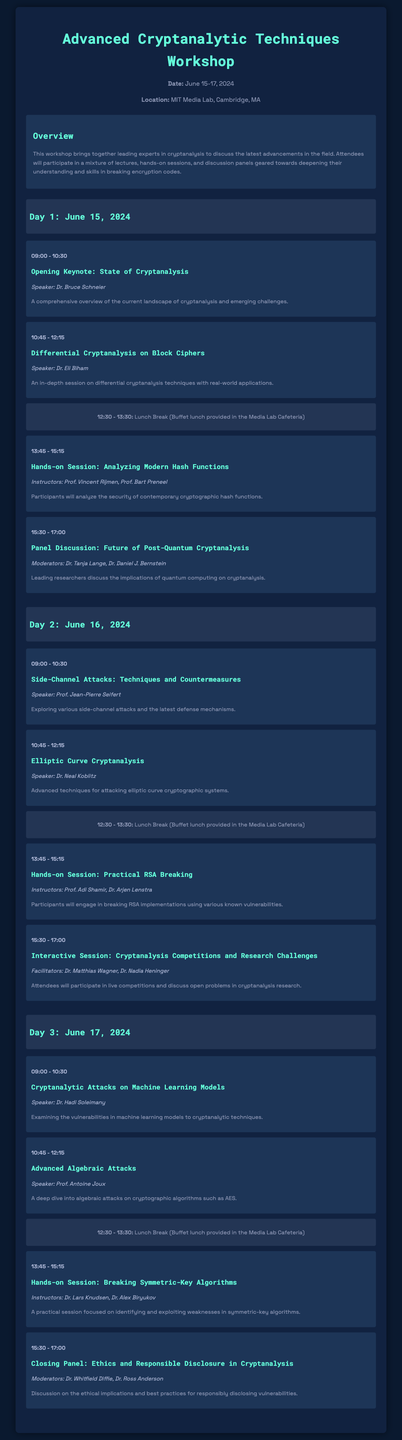What are the workshop dates? The workshop dates are specified in the document header, indicating the event will take place from June 15 to June 17, 2024.
Answer: June 15-17, 2024 Where is the workshop located? The location of the workshop is mentioned in the workshop info section, stating that it will be held at the MIT Media Lab in Cambridge, MA.
Answer: MIT Media Lab, Cambridge, MA Who is the speaker for the opening keynote? The speaker for the opening keynote is identified within the Day 1 sessions, where it lists Dr. Bruce Schneier as the speaker for the session titled "State of Cryptanalysis."
Answer: Dr. Bruce Schneier What time does the lunch break start on Day 2? The lunch break timing is consistently noted across the days; for Day 2, the start time is detailed in the session listing as 12:30 PM.
Answer: 12:30 Which session includes hands-on participation? Hands-on sessions are specified throughout the schedule; specifically, "Hands-on Session: Breaking Symmetric-Key Algorithms" on Day 3 offers practical engagement.
Answer: Hands-on Session: Breaking Symmetric-Key Algorithms What is the main topic of Day 3's closing panel? The closing panel of Day 3 addresses the ethical implications in cryptanalysis as outlined in the document under the session titled "Closing Panel: Ethics and Responsible Disclosure in Cryptanalysis."
Answer: Ethics and Responsible Disclosure Which day features a session on elliptic curve cryptanalysis? The document lists sessions organized by day, with the session on elliptic curve cryptanalysis occurring on Day 2.
Answer: Day 2 Who are the facilitators for the interactive session on Day 2? The document lists Dr. Matthias Wagner and Dr. Nadia Heninger as the facilitators for the interactive session on Day 2, titled "Cryptanalysis Competitions and Research Challenges."
Answer: Dr. Matthias Wagner, Dr. Nadia Heninger 